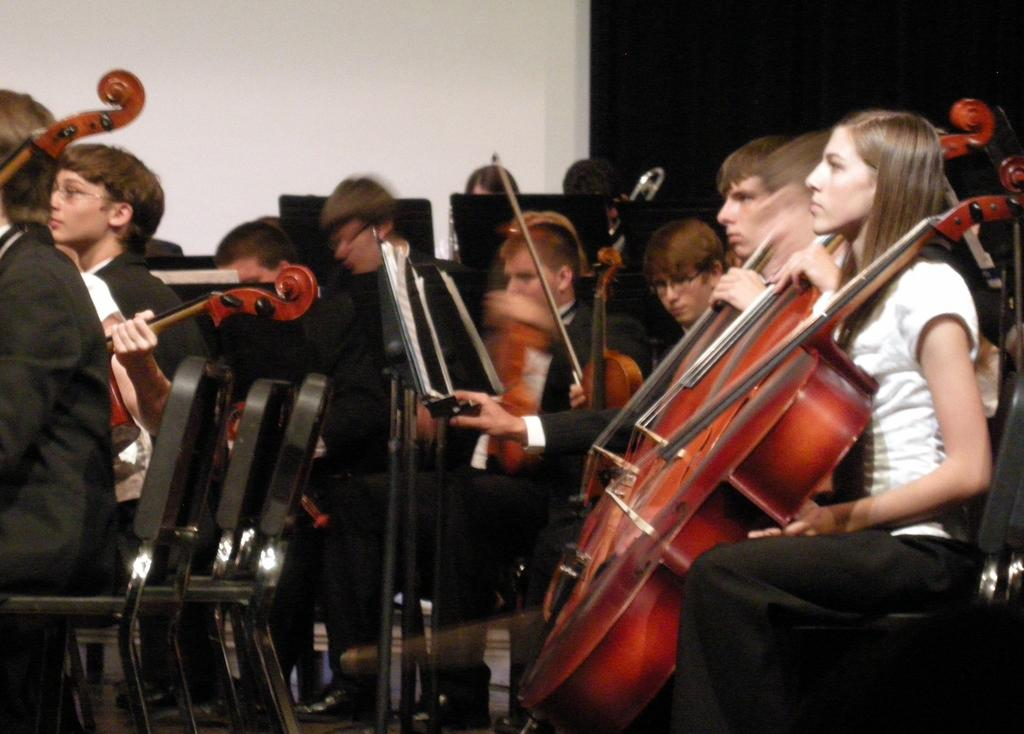Who or what can be seen in the image? There are people in the image. What are the people holding in the image? The people are holding violins. How are the people positioned in the image? The people are seated on chairs. What type of hat can be seen on the violin in the image? There are no hats present in the image, and the violins are not wearing any accessories. What sound does the alarm make in the image? There is no alarm present in the image. 